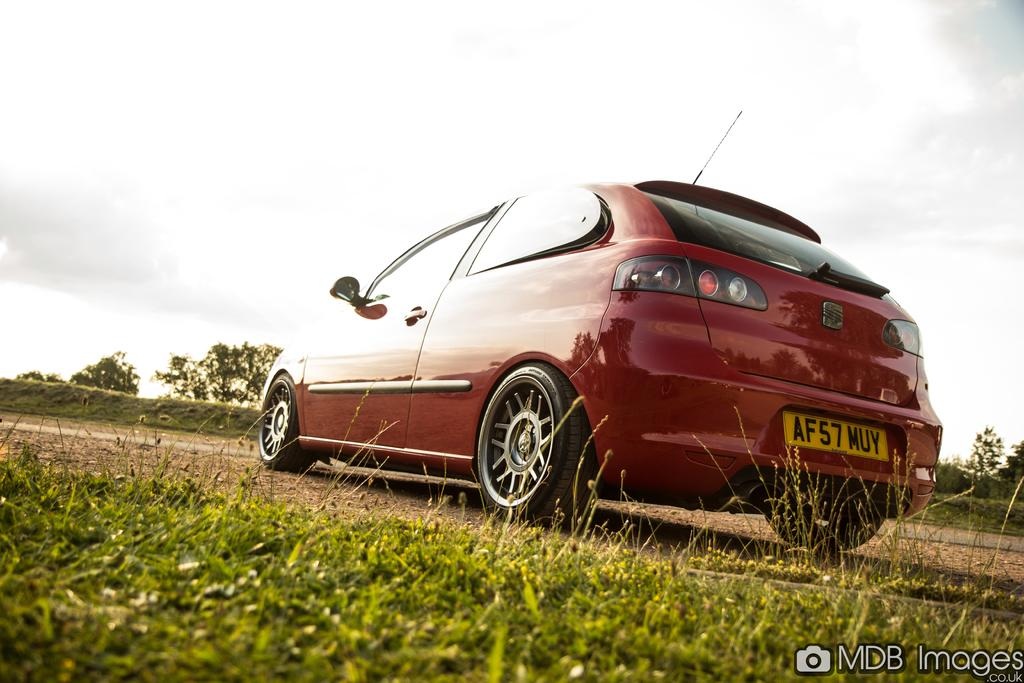What is the main subject of the picture? The main subject of the picture is a car. What type of natural environment is visible in the picture? There is grass and trees visible in the picture. What can be seen in the background of the picture? The sky is visible in the background of the picture. Is there any additional information about the image itself? Yes, there is a watermark on the image. How much money is the beggar asking for in the image? There is no beggar present in the image, so it is not possible to determine how much money they might be asking for. 